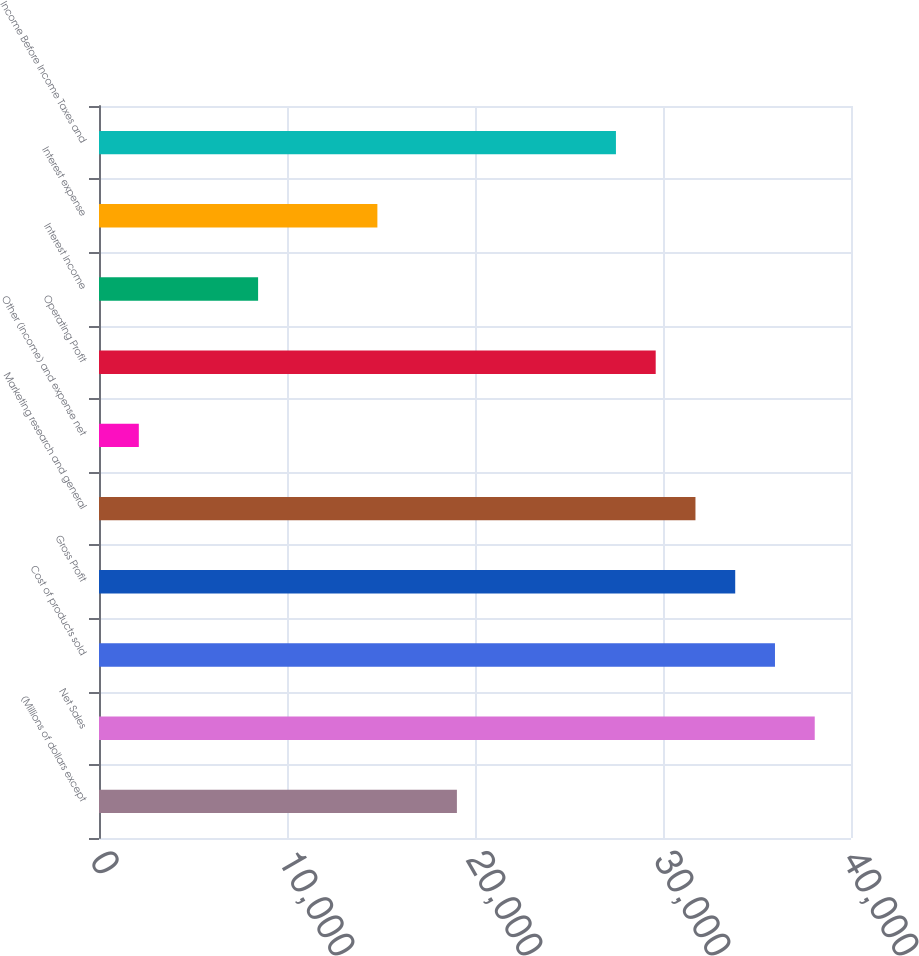Convert chart to OTSL. <chart><loc_0><loc_0><loc_500><loc_500><bar_chart><fcel>(Millions of dollars except<fcel>Net Sales<fcel>Cost of products sold<fcel>Gross Profit<fcel>Marketing research and general<fcel>Other (income) and expense net<fcel>Operating Profit<fcel>Interest income<fcel>Interest expense<fcel>Income Before Income Taxes and<nl><fcel>19037.2<fcel>38071.1<fcel>35956.2<fcel>33841.3<fcel>31726.4<fcel>2118.12<fcel>29611.6<fcel>8462.76<fcel>14807.4<fcel>27496.7<nl></chart> 